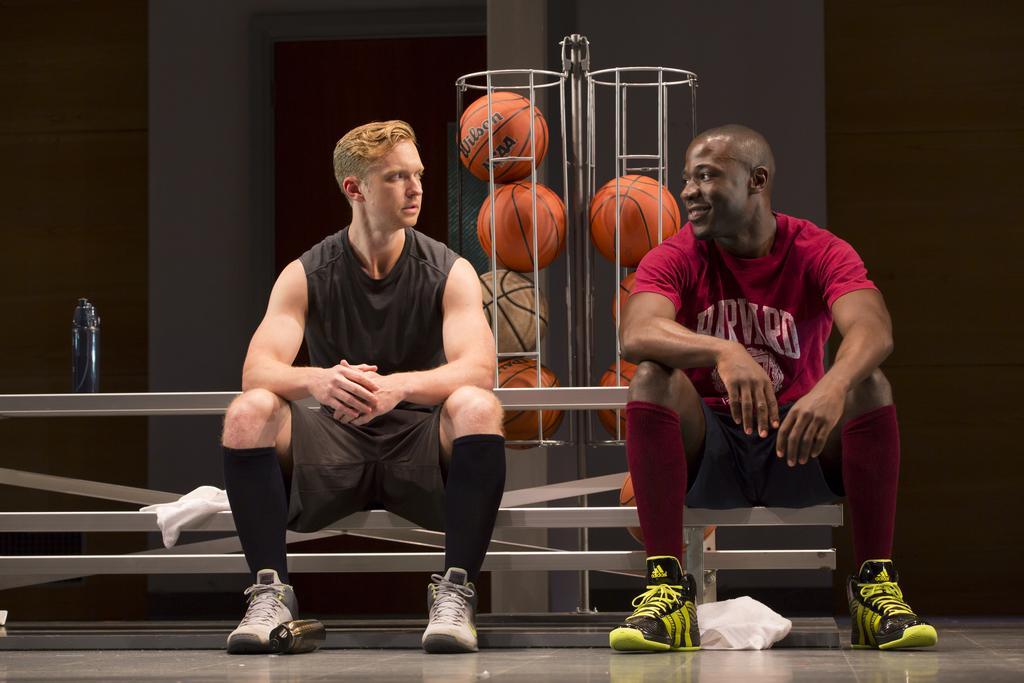Please provide a concise description of this image. This picture shows the inner view of a building. Two men sitting, some objects are on the surface, one water bottle on the surface, some balls and one cream color wall. 